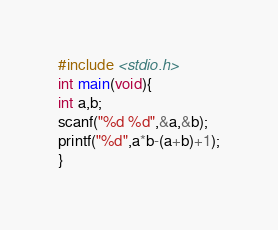<code> <loc_0><loc_0><loc_500><loc_500><_C_>#include <stdio.h>
int main(void){
int a,b;
scanf("%d %d",&a,&b);
printf("%d",a*b-(a+b)+1);
}</code> 